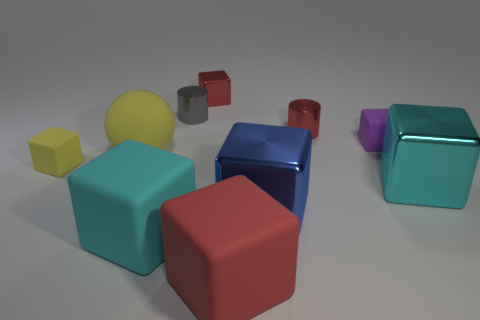Subtract all blue blocks. How many blocks are left? 6 Subtract all large red cubes. How many cubes are left? 6 Subtract all purple blocks. Subtract all gray cylinders. How many blocks are left? 6 Subtract all cubes. How many objects are left? 3 Add 3 yellow matte things. How many yellow matte things are left? 5 Add 2 tiny green cylinders. How many tiny green cylinders exist? 2 Subtract 0 green balls. How many objects are left? 10 Subtract all gray objects. Subtract all large cyan metallic cubes. How many objects are left? 8 